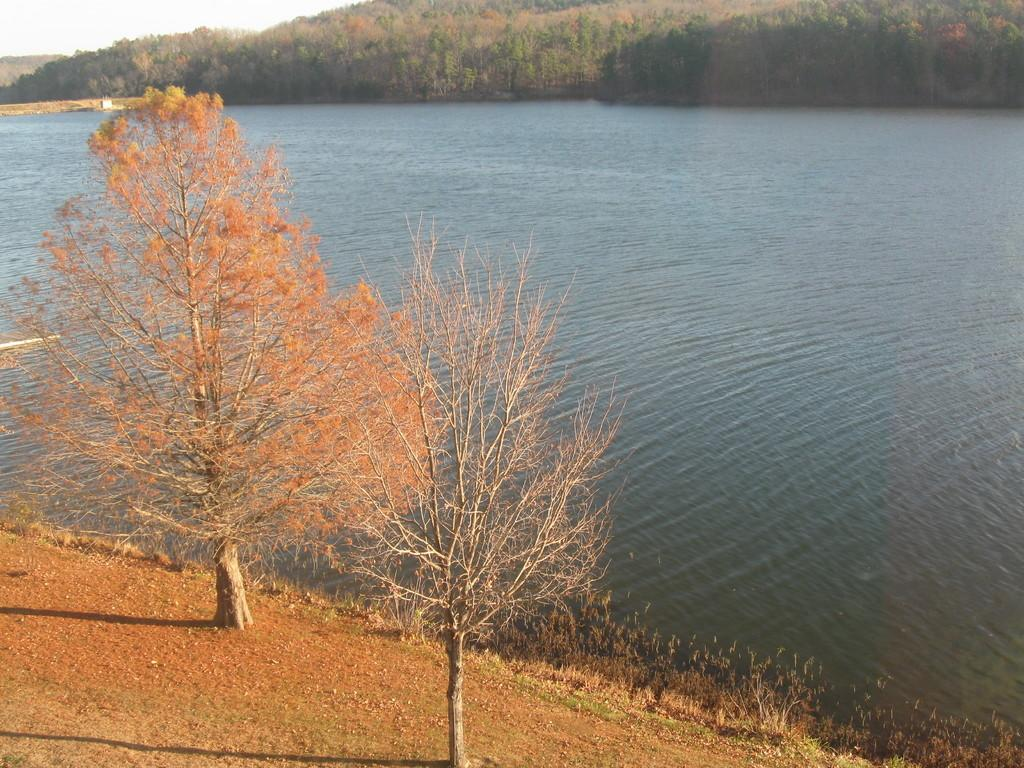What type of vegetation can be seen in the image? There are trees and plants in the image. What natural element is visible in the image? There is water visible in the image. What can be seen in the background of the image? The sky is visible in the background of the image. What type of prose is being taught in the class depicted in the image? There is no class present in the image, so it is not possible to determine what type of prose might be taught. 